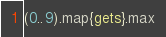<code> <loc_0><loc_0><loc_500><loc_500><_Ruby_>(0..9).map{gets}.max</code> 